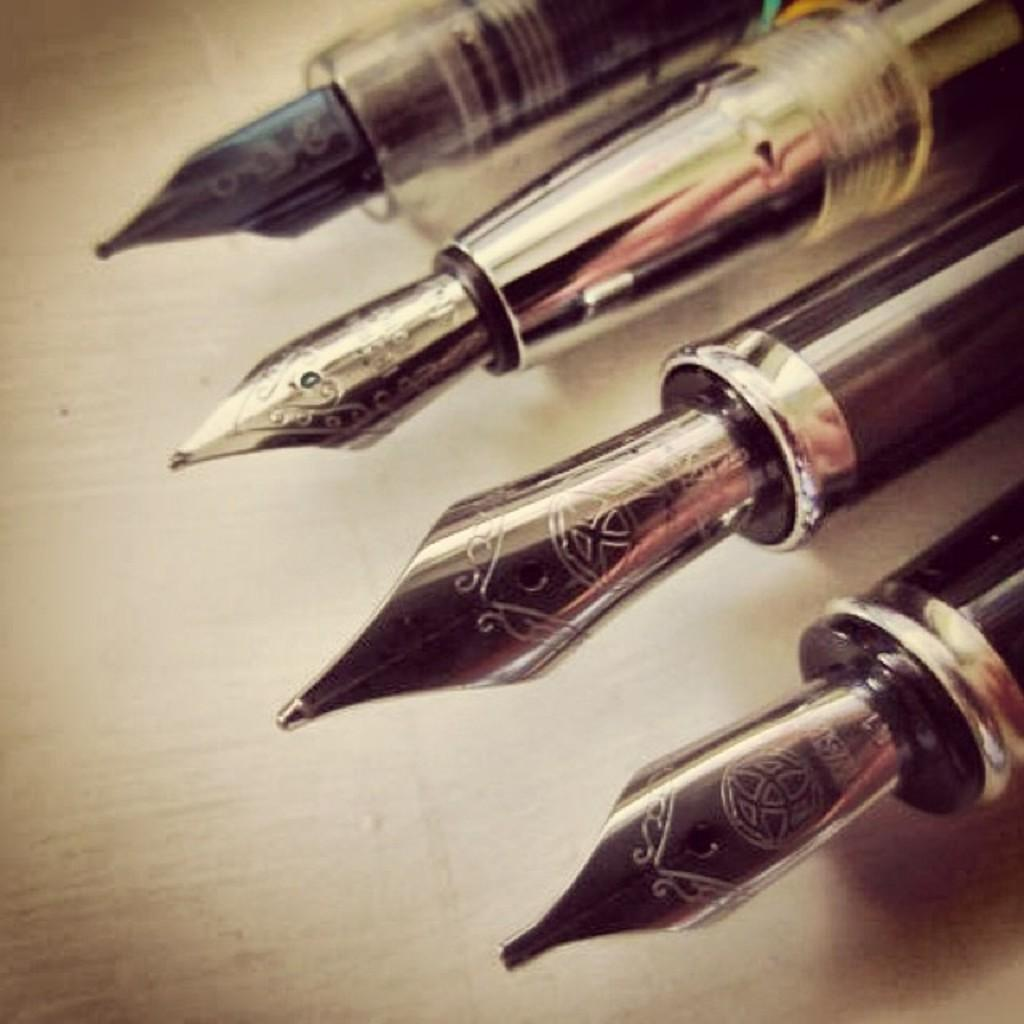What objects can be seen in the image? There are pens in the image. Can you describe the pens in more detail? Unfortunately, the provided facts do not offer more detail about the pens. Are the pens being used for any specific purpose in the image? The provided facts do not mention any specific purpose for the pens. How does the mitten help the pens in the image? There is no mitten present in the image, so it cannot help the pens. 